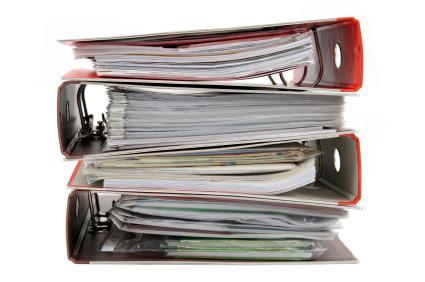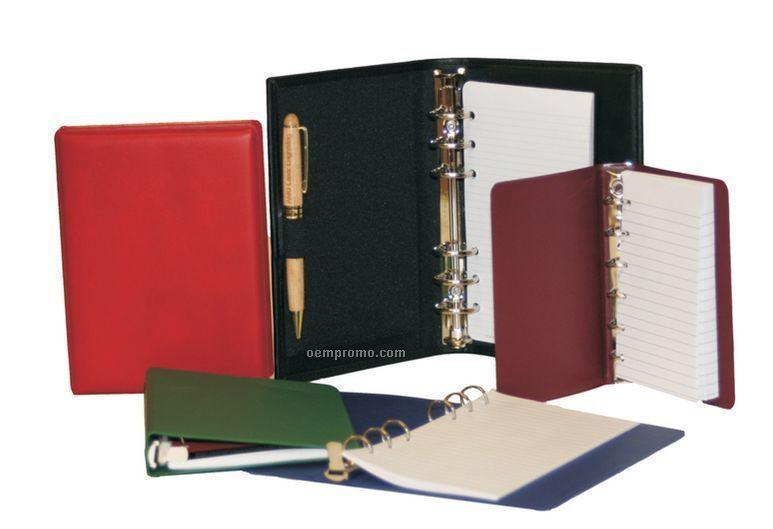The first image is the image on the left, the second image is the image on the right. Given the left and right images, does the statement "The left image has at least four binders stacked vertically in it." hold true? Answer yes or no. Yes. The first image is the image on the left, the second image is the image on the right. For the images shown, is this caption "binders are stacked on their sides with paper inside" true? Answer yes or no. Yes. 